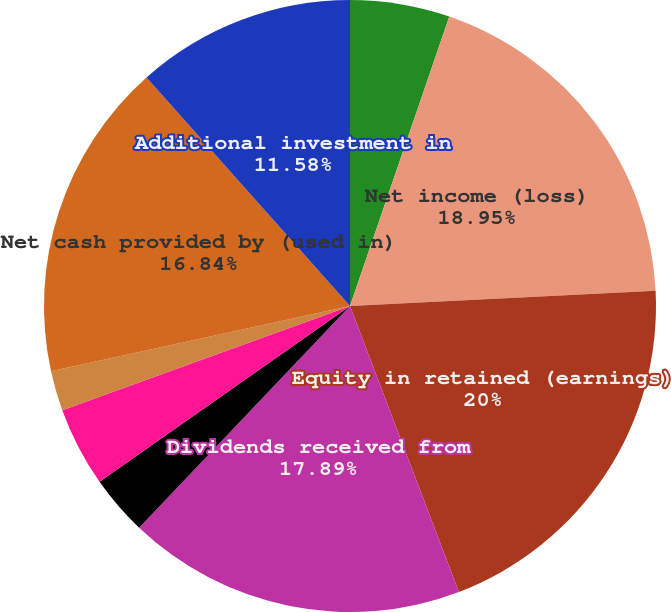<chart> <loc_0><loc_0><loc_500><loc_500><pie_chart><fcel>(Dollars in thousands)<fcel>Net income (loss)<fcel>Equity in retained (earnings)<fcel>Dividends received from<fcel>Change in other assets and<fcel>Increase (decrease) in due<fcel>Amortization of bond premium<fcel>Non-cash compensation expense<fcel>Net cash provided by (used in)<fcel>Additional investment in<nl><fcel>5.26%<fcel>18.95%<fcel>20.0%<fcel>17.89%<fcel>3.16%<fcel>4.21%<fcel>0.0%<fcel>2.11%<fcel>16.84%<fcel>11.58%<nl></chart> 